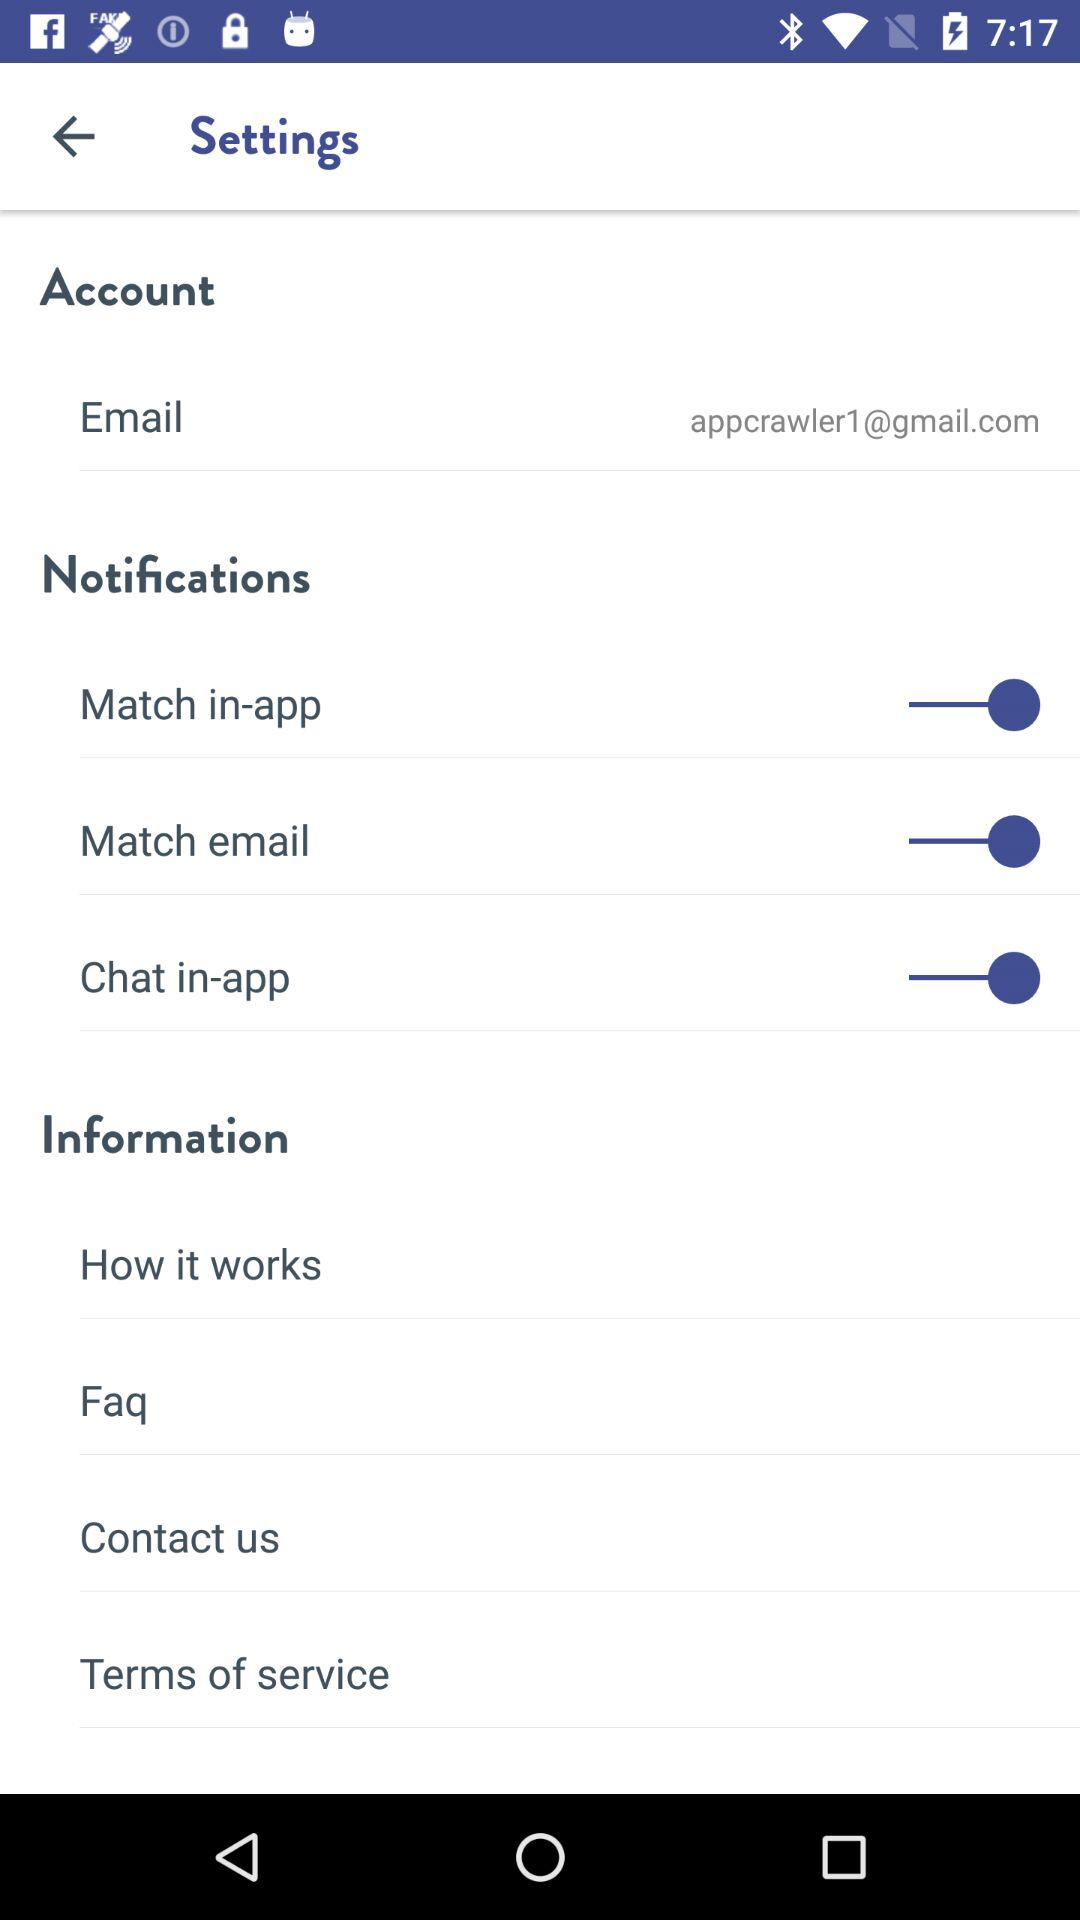What is the email address? The email address is appcrawler1@gmail.com. 